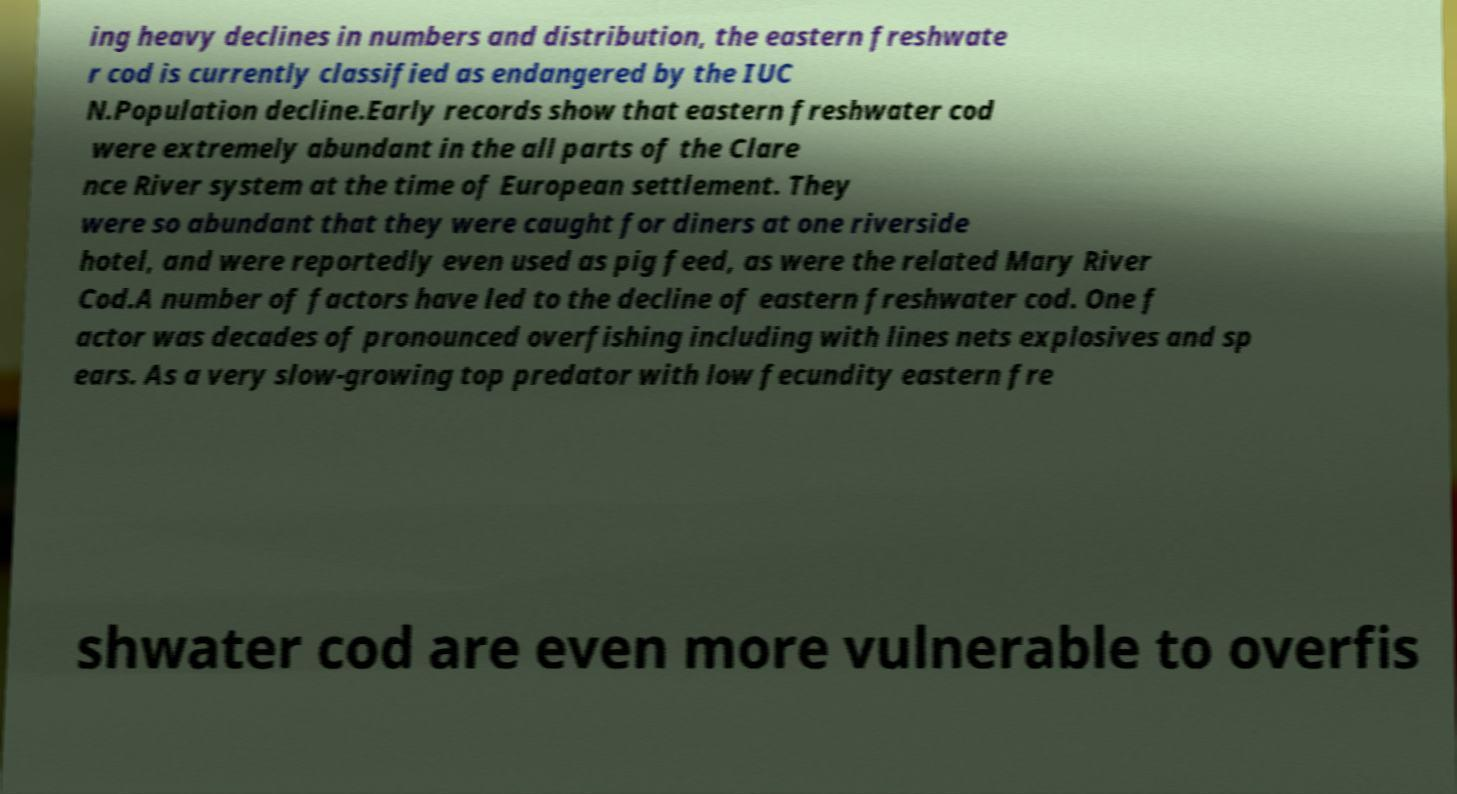For documentation purposes, I need the text within this image transcribed. Could you provide that? ing heavy declines in numbers and distribution, the eastern freshwate r cod is currently classified as endangered by the IUC N.Population decline.Early records show that eastern freshwater cod were extremely abundant in the all parts of the Clare nce River system at the time of European settlement. They were so abundant that they were caught for diners at one riverside hotel, and were reportedly even used as pig feed, as were the related Mary River Cod.A number of factors have led to the decline of eastern freshwater cod. One f actor was decades of pronounced overfishing including with lines nets explosives and sp ears. As a very slow-growing top predator with low fecundity eastern fre shwater cod are even more vulnerable to overfis 